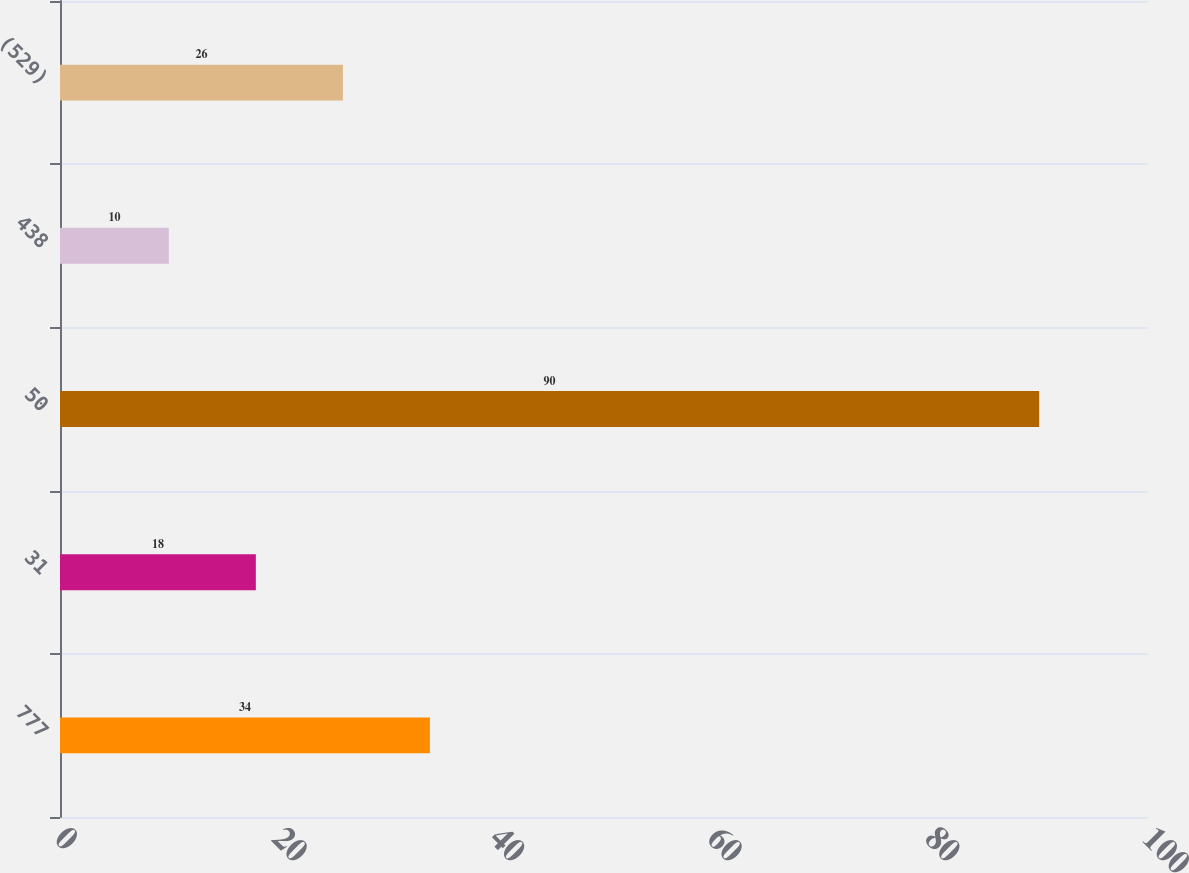Convert chart. <chart><loc_0><loc_0><loc_500><loc_500><bar_chart><fcel>777<fcel>31<fcel>50<fcel>438<fcel>(529)<nl><fcel>34<fcel>18<fcel>90<fcel>10<fcel>26<nl></chart> 